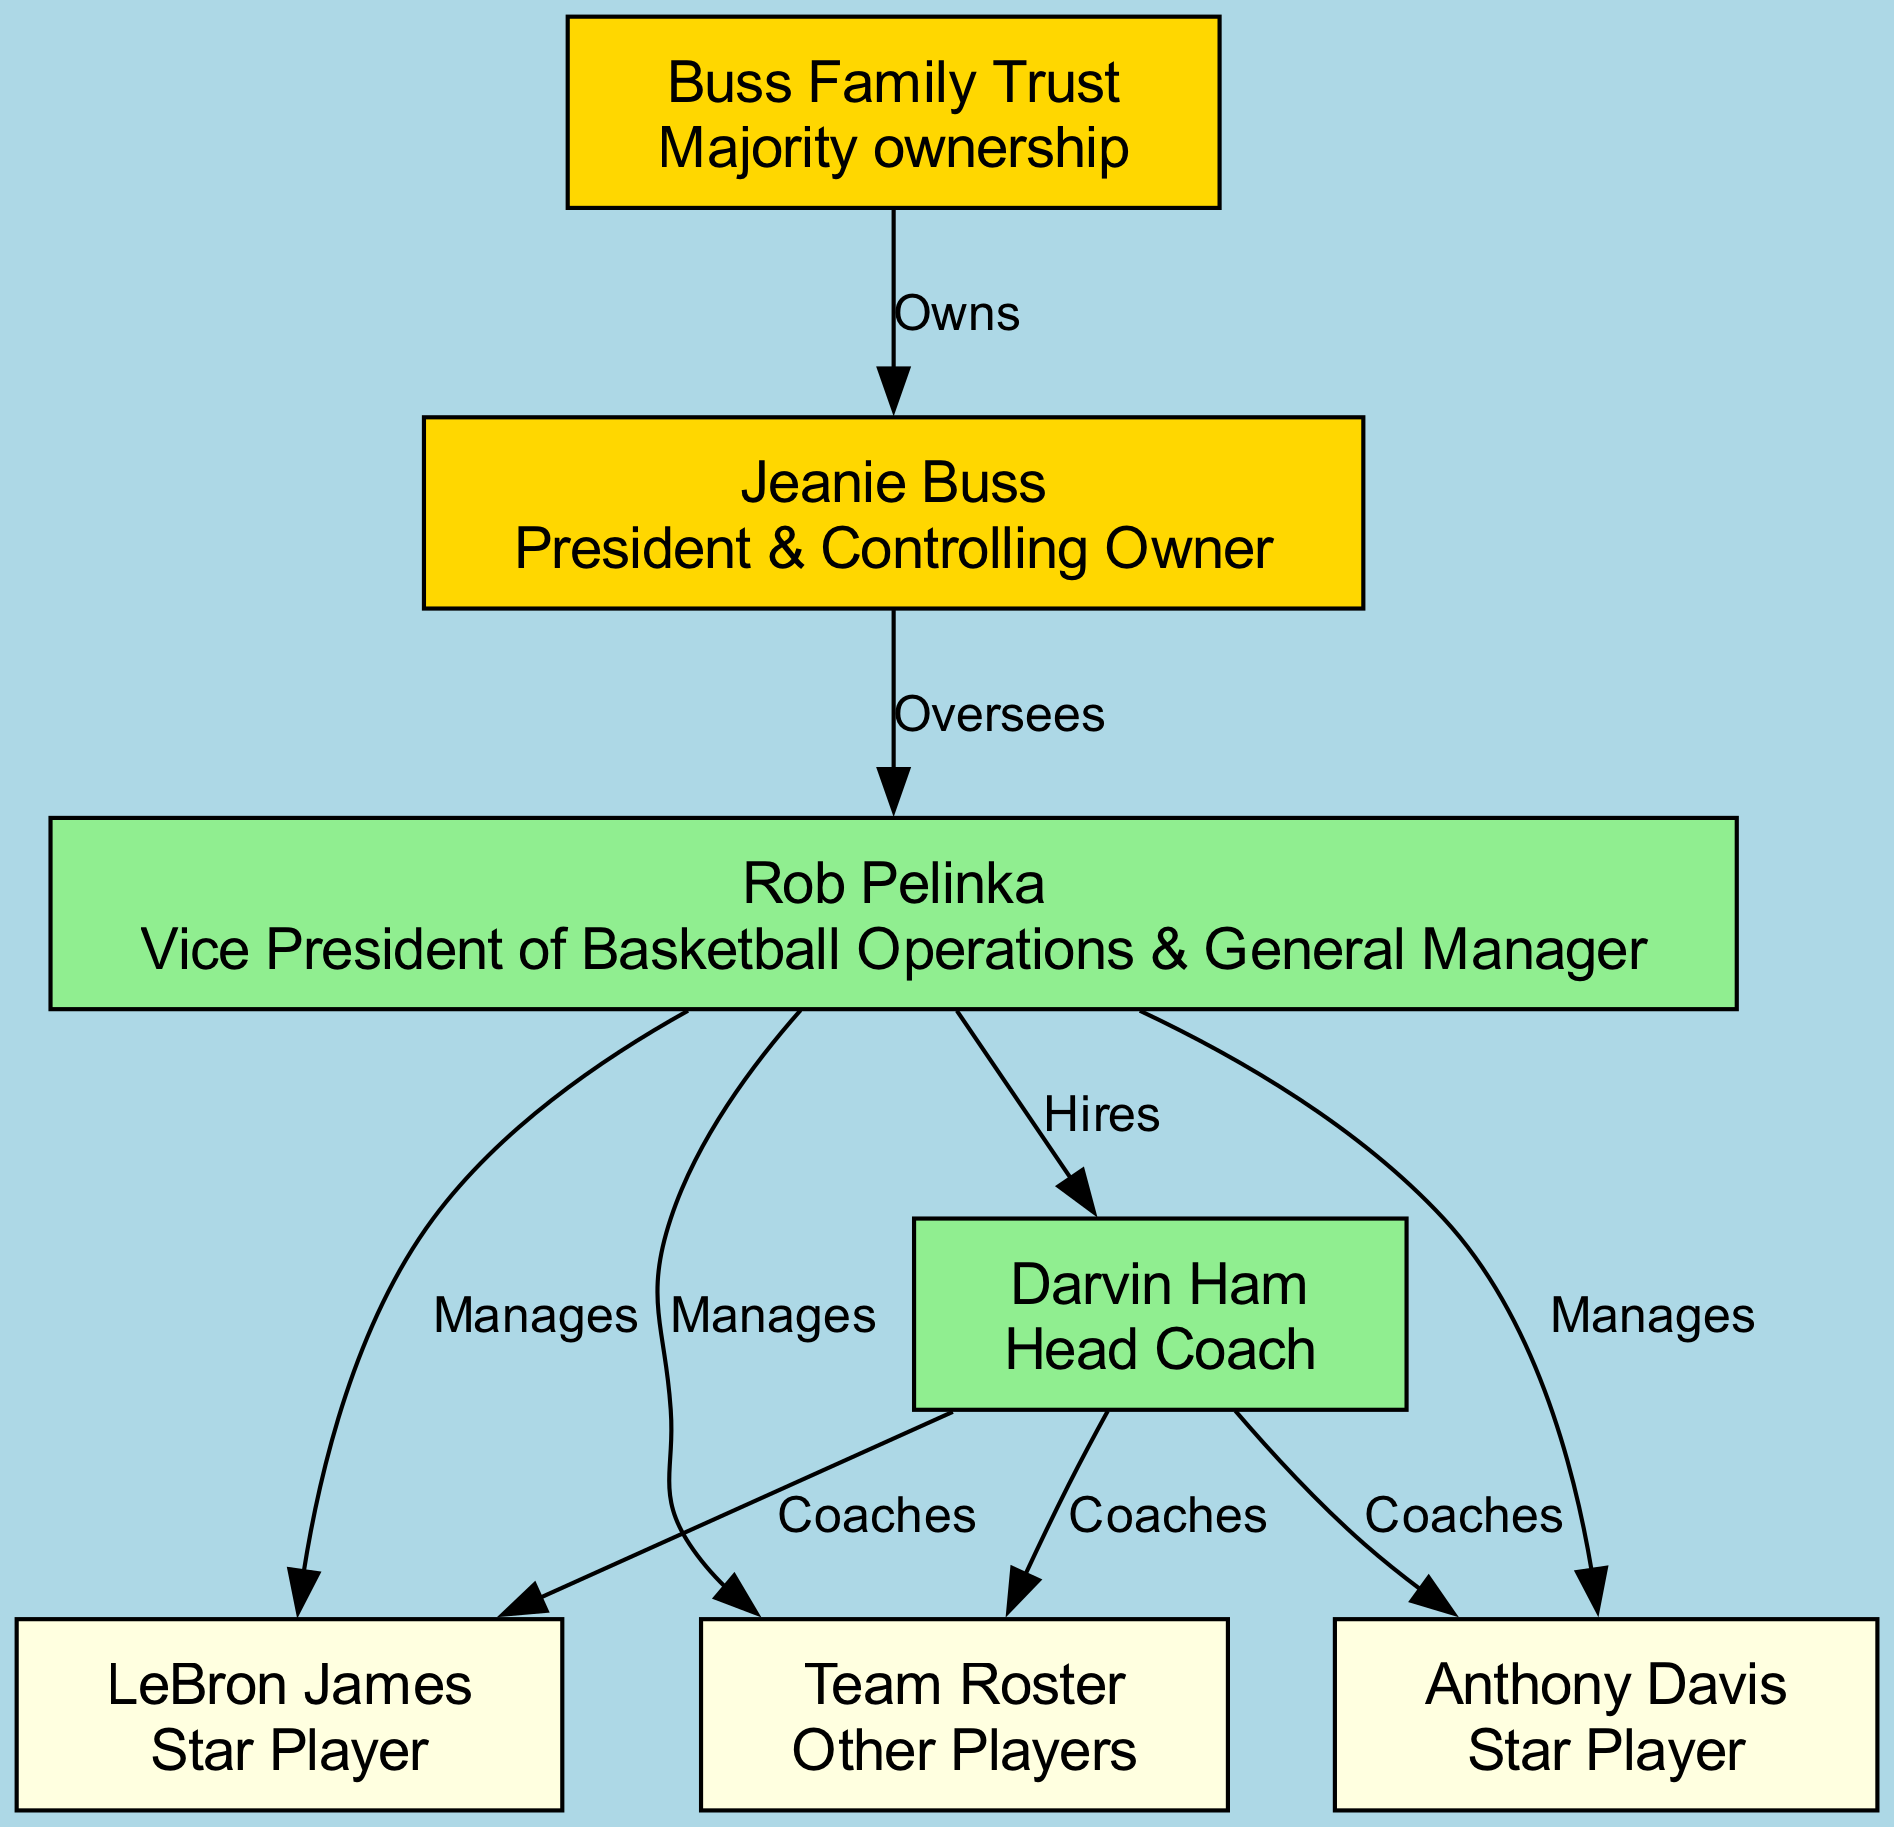What does the Buss Family Trust do? The Buss Family Trust is labeled in the diagram as having the relationship "Owns" with Jeanie Buss, indicating that it provides majority ownership of the franchise.
Answer: Majority ownership Who oversees Rob Pelinka? According to the diagram, Jeanie Buss has an "Oversees" relationship with Rob Pelinka, which means she provides oversight in his role as Vice President of Basketball Operations & General Manager.
Answer: Jeanie Buss How many players are directly managed by Rob Pelinka? The diagram shows that Rob Pelinka manages three entities: LeBron James, Anthony Davis, and the Team Roster (which represents other players), therefore he manages a total of three players/entities.
Answer: 3 What is the relationship between Darvin Ham and the team roster? The diagram indicates that Darvin Ham, as the Head Coach, has a "Coaches" relationship with the Team Roster, meaning he is responsible for coaching the players included in the Team Roster.
Answer: Coaches Which node(s) does Rob Pelinka manage? The edges from Rob Pelinka show that he manages LeBron James, Anthony Davis, and the Team Roster, linking them to him with the label "Manages." Therefore, the nodes he manages are those three players/entities.
Answer: LeBron James, Anthony Davis, Team Roster What is the primary function of Jeanie Buss in the Lakers franchise? Jeanie Buss is designated in the diagram as the "President & Controlling Owner," indicating her main function is as the chief executive overseeing franchise operations.
Answer: President & Controlling Owner How many coaching relationships are there involving Darvin Ham? The diagram provides that Darvin Ham has coaching relationships with all three entities he is linked to (LeBron James, Anthony Davis, and the Team Roster). Therefore, there are three coaching relationships.
Answer: 3 What is the highest level of ownership in the Lakers franchise? The diagram shows the Buss Family Trust at the top as the entity "Owns" Jeanie Buss, indicating it represents the highest level of ownership within the franchise structure.
Answer: Buss Family Trust 